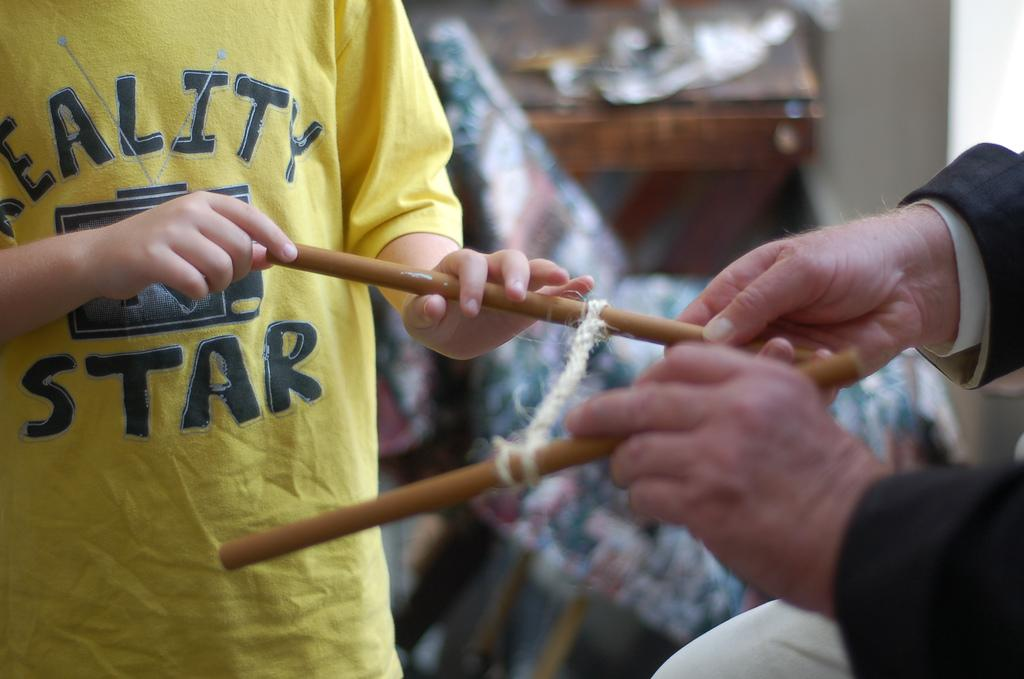Provide a one-sentence caption for the provided image. a person with a yellow shirt that says the word STAR on it. 